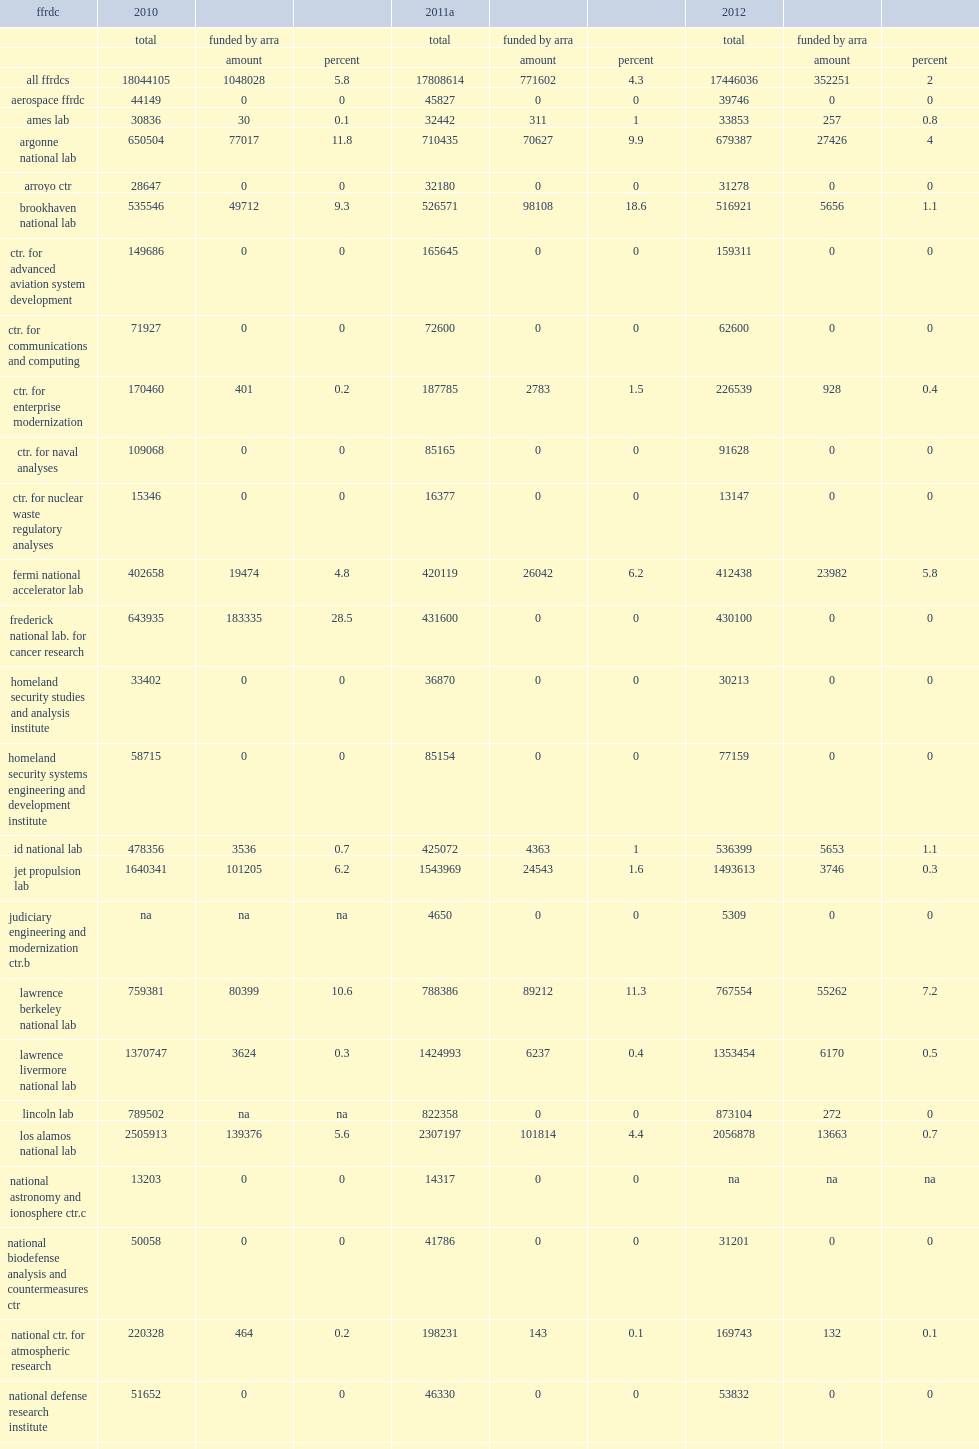How many thousand dollars did the nation's 39 federally funded research and development centers (ffrdcs) spend on research and development in fy 2012? 17446036.0. How many thousand dollars did the nation's 39 federally funded research and development centers (ffrdcs) spend on research and development in fy 2011? 17808614.0. 